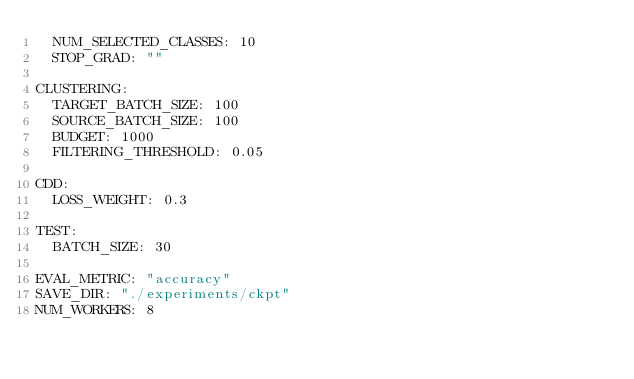Convert code to text. <code><loc_0><loc_0><loc_500><loc_500><_YAML_>  NUM_SELECTED_CLASSES: 10
  STOP_GRAD: ""

CLUSTERING:
  TARGET_BATCH_SIZE: 100
  SOURCE_BATCH_SIZE: 100
  BUDGET: 1000
  FILTERING_THRESHOLD: 0.05

CDD:
  LOSS_WEIGHT: 0.3

TEST:
  BATCH_SIZE: 30

EVAL_METRIC: "accuracy"
SAVE_DIR: "./experiments/ckpt"
NUM_WORKERS: 8
</code> 